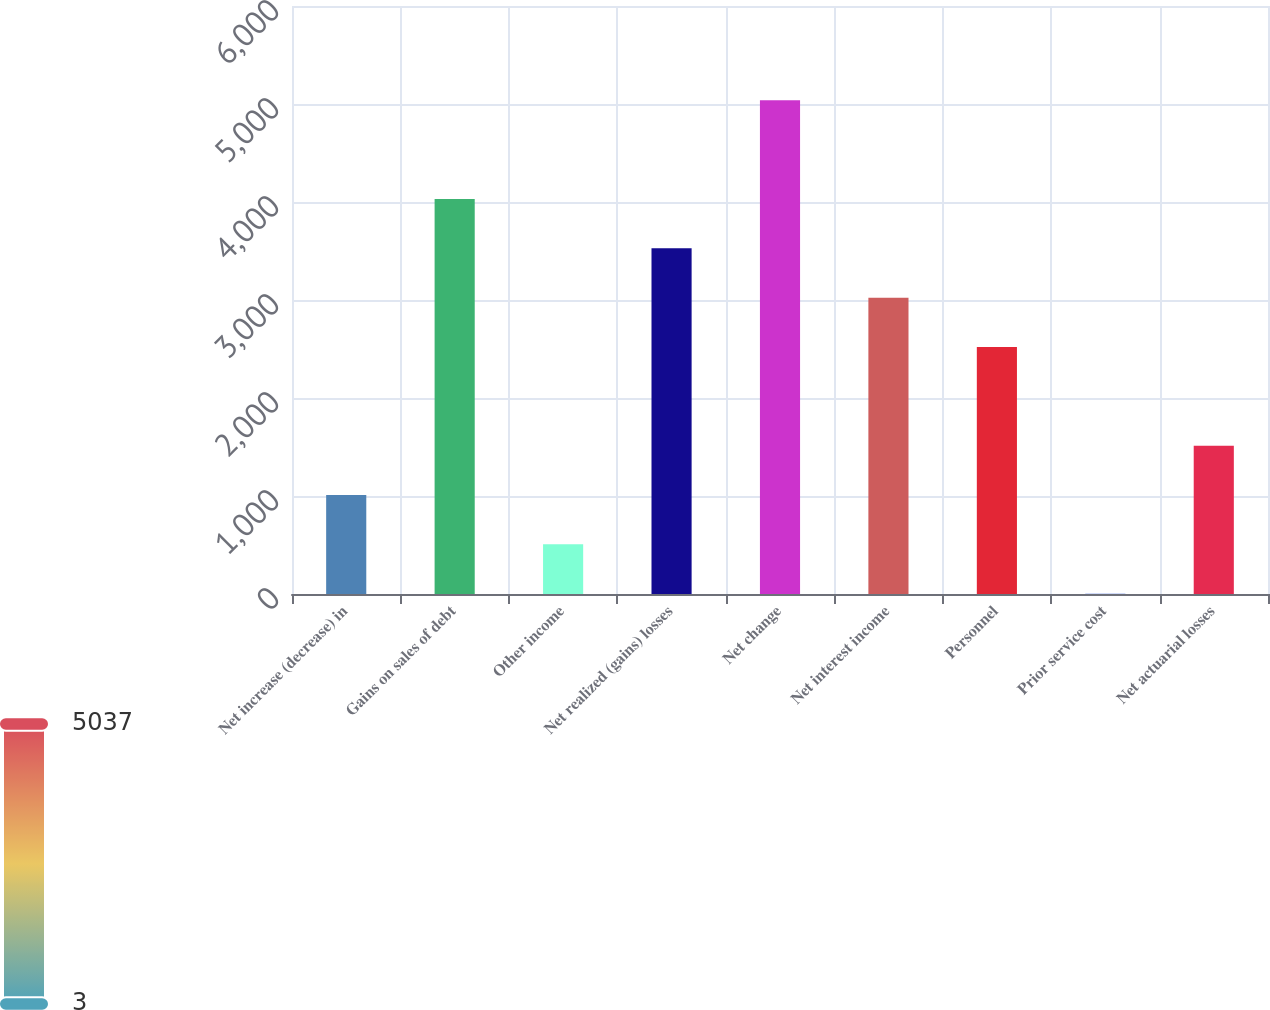Convert chart to OTSL. <chart><loc_0><loc_0><loc_500><loc_500><bar_chart><fcel>Net increase (decrease) in<fcel>Gains on sales of debt<fcel>Other income<fcel>Net realized (gains) losses<fcel>Net change<fcel>Net interest income<fcel>Personnel<fcel>Prior service cost<fcel>Net actuarial losses<nl><fcel>1009.8<fcel>4030.2<fcel>506.4<fcel>3526.8<fcel>5037<fcel>3023.4<fcel>2520<fcel>3<fcel>1513.2<nl></chart> 